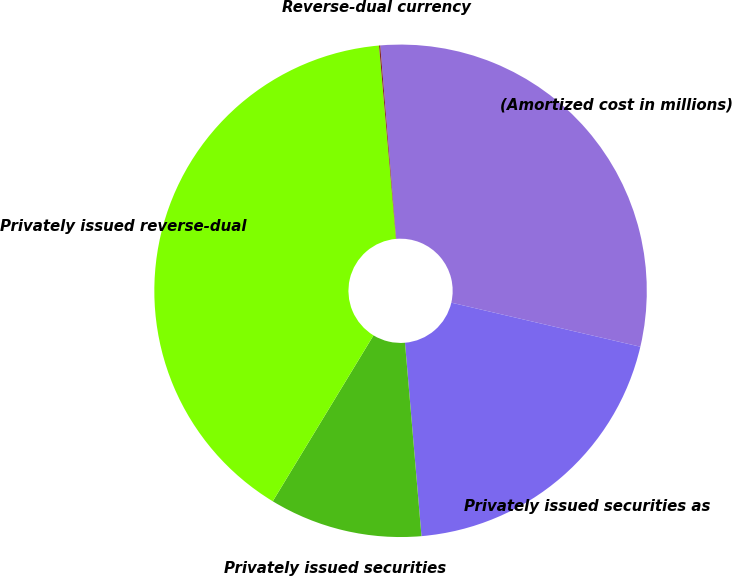Convert chart. <chart><loc_0><loc_0><loc_500><loc_500><pie_chart><fcel>(Amortized cost in millions)<fcel>Privately issued securities as<fcel>Privately issued securities<fcel>Privately issued reverse-dual<fcel>Reverse-dual currency<nl><fcel>29.96%<fcel>20.0%<fcel>10.04%<fcel>39.92%<fcel>0.08%<nl></chart> 